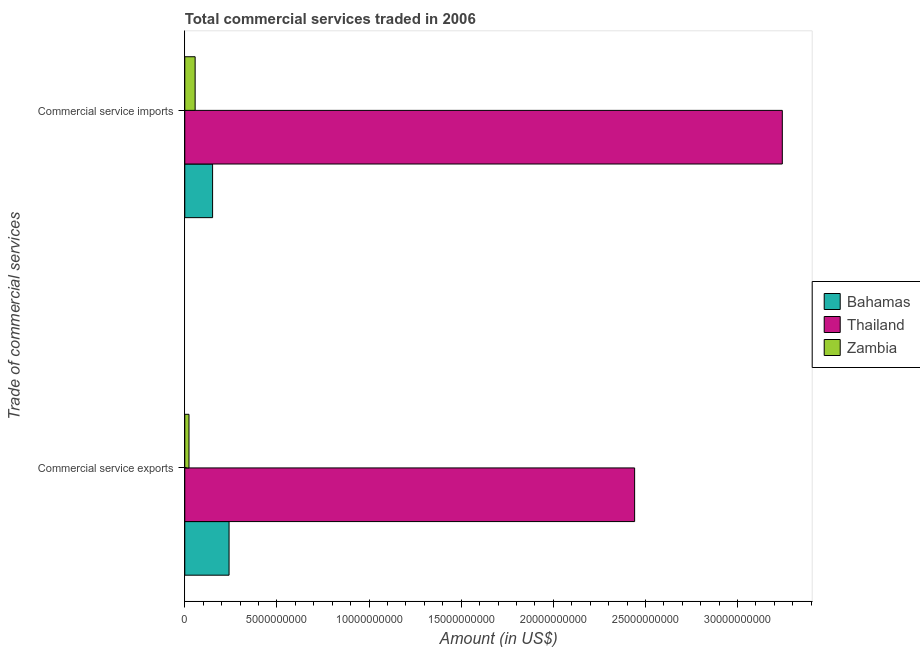Are the number of bars on each tick of the Y-axis equal?
Keep it short and to the point. Yes. How many bars are there on the 2nd tick from the top?
Your answer should be very brief. 3. How many bars are there on the 2nd tick from the bottom?
Your response must be concise. 3. What is the label of the 2nd group of bars from the top?
Keep it short and to the point. Commercial service exports. What is the amount of commercial service exports in Zambia?
Your answer should be compact. 2.29e+08. Across all countries, what is the maximum amount of commercial service exports?
Provide a short and direct response. 2.44e+1. Across all countries, what is the minimum amount of commercial service imports?
Offer a terse response. 5.62e+08. In which country was the amount of commercial service exports maximum?
Your response must be concise. Thailand. In which country was the amount of commercial service imports minimum?
Your answer should be very brief. Zambia. What is the total amount of commercial service imports in the graph?
Your response must be concise. 3.45e+1. What is the difference between the amount of commercial service exports in Thailand and that in Bahamas?
Provide a short and direct response. 2.20e+1. What is the difference between the amount of commercial service imports in Bahamas and the amount of commercial service exports in Thailand?
Keep it short and to the point. -2.29e+1. What is the average amount of commercial service imports per country?
Provide a succinct answer. 1.15e+1. What is the difference between the amount of commercial service imports and amount of commercial service exports in Bahamas?
Your answer should be compact. -8.94e+08. What is the ratio of the amount of commercial service exports in Thailand to that in Zambia?
Provide a succinct answer. 106.6. Is the amount of commercial service exports in Bahamas less than that in Zambia?
Provide a short and direct response. No. In how many countries, is the amount of commercial service imports greater than the average amount of commercial service imports taken over all countries?
Make the answer very short. 1. What does the 2nd bar from the top in Commercial service imports represents?
Your answer should be very brief. Thailand. What does the 1st bar from the bottom in Commercial service exports represents?
Provide a succinct answer. Bahamas. How many bars are there?
Give a very brief answer. 6. What is the difference between two consecutive major ticks on the X-axis?
Provide a succinct answer. 5.00e+09. Are the values on the major ticks of X-axis written in scientific E-notation?
Offer a very short reply. No. Does the graph contain any zero values?
Make the answer very short. No. Where does the legend appear in the graph?
Your response must be concise. Center right. How are the legend labels stacked?
Make the answer very short. Vertical. What is the title of the graph?
Your response must be concise. Total commercial services traded in 2006. Does "Isle of Man" appear as one of the legend labels in the graph?
Give a very brief answer. No. What is the label or title of the X-axis?
Make the answer very short. Amount (in US$). What is the label or title of the Y-axis?
Ensure brevity in your answer.  Trade of commercial services. What is the Amount (in US$) in Bahamas in Commercial service exports?
Your response must be concise. 2.40e+09. What is the Amount (in US$) of Thailand in Commercial service exports?
Provide a short and direct response. 2.44e+1. What is the Amount (in US$) in Zambia in Commercial service exports?
Provide a succinct answer. 2.29e+08. What is the Amount (in US$) in Bahamas in Commercial service imports?
Give a very brief answer. 1.51e+09. What is the Amount (in US$) of Thailand in Commercial service imports?
Offer a terse response. 3.24e+1. What is the Amount (in US$) in Zambia in Commercial service imports?
Provide a short and direct response. 5.62e+08. Across all Trade of commercial services, what is the maximum Amount (in US$) of Bahamas?
Give a very brief answer. 2.40e+09. Across all Trade of commercial services, what is the maximum Amount (in US$) of Thailand?
Your response must be concise. 3.24e+1. Across all Trade of commercial services, what is the maximum Amount (in US$) in Zambia?
Offer a very short reply. 5.62e+08. Across all Trade of commercial services, what is the minimum Amount (in US$) in Bahamas?
Your response must be concise. 1.51e+09. Across all Trade of commercial services, what is the minimum Amount (in US$) in Thailand?
Provide a succinct answer. 2.44e+1. Across all Trade of commercial services, what is the minimum Amount (in US$) in Zambia?
Provide a succinct answer. 2.29e+08. What is the total Amount (in US$) in Bahamas in the graph?
Your answer should be very brief. 3.91e+09. What is the total Amount (in US$) of Thailand in the graph?
Your response must be concise. 5.68e+1. What is the total Amount (in US$) in Zambia in the graph?
Your answer should be very brief. 7.91e+08. What is the difference between the Amount (in US$) of Bahamas in Commercial service exports and that in Commercial service imports?
Your answer should be compact. 8.94e+08. What is the difference between the Amount (in US$) in Thailand in Commercial service exports and that in Commercial service imports?
Your answer should be compact. -8.02e+09. What is the difference between the Amount (in US$) in Zambia in Commercial service exports and that in Commercial service imports?
Offer a very short reply. -3.33e+08. What is the difference between the Amount (in US$) of Bahamas in Commercial service exports and the Amount (in US$) of Thailand in Commercial service imports?
Your response must be concise. -3.00e+1. What is the difference between the Amount (in US$) of Bahamas in Commercial service exports and the Amount (in US$) of Zambia in Commercial service imports?
Keep it short and to the point. 1.84e+09. What is the difference between the Amount (in US$) of Thailand in Commercial service exports and the Amount (in US$) of Zambia in Commercial service imports?
Provide a short and direct response. 2.39e+1. What is the average Amount (in US$) of Bahamas per Trade of commercial services?
Ensure brevity in your answer.  1.96e+09. What is the average Amount (in US$) in Thailand per Trade of commercial services?
Offer a terse response. 2.84e+1. What is the average Amount (in US$) in Zambia per Trade of commercial services?
Offer a terse response. 3.96e+08. What is the difference between the Amount (in US$) of Bahamas and Amount (in US$) of Thailand in Commercial service exports?
Your answer should be compact. -2.20e+1. What is the difference between the Amount (in US$) of Bahamas and Amount (in US$) of Zambia in Commercial service exports?
Your answer should be very brief. 2.17e+09. What is the difference between the Amount (in US$) in Thailand and Amount (in US$) in Zambia in Commercial service exports?
Provide a short and direct response. 2.42e+1. What is the difference between the Amount (in US$) of Bahamas and Amount (in US$) of Thailand in Commercial service imports?
Keep it short and to the point. -3.09e+1. What is the difference between the Amount (in US$) of Bahamas and Amount (in US$) of Zambia in Commercial service imports?
Ensure brevity in your answer.  9.48e+08. What is the difference between the Amount (in US$) of Thailand and Amount (in US$) of Zambia in Commercial service imports?
Your answer should be compact. 3.19e+1. What is the ratio of the Amount (in US$) of Bahamas in Commercial service exports to that in Commercial service imports?
Keep it short and to the point. 1.59. What is the ratio of the Amount (in US$) of Thailand in Commercial service exports to that in Commercial service imports?
Your response must be concise. 0.75. What is the ratio of the Amount (in US$) in Zambia in Commercial service exports to that in Commercial service imports?
Provide a short and direct response. 0.41. What is the difference between the highest and the second highest Amount (in US$) in Bahamas?
Keep it short and to the point. 8.94e+08. What is the difference between the highest and the second highest Amount (in US$) in Thailand?
Offer a terse response. 8.02e+09. What is the difference between the highest and the second highest Amount (in US$) of Zambia?
Offer a very short reply. 3.33e+08. What is the difference between the highest and the lowest Amount (in US$) in Bahamas?
Offer a very short reply. 8.94e+08. What is the difference between the highest and the lowest Amount (in US$) of Thailand?
Offer a terse response. 8.02e+09. What is the difference between the highest and the lowest Amount (in US$) in Zambia?
Offer a terse response. 3.33e+08. 